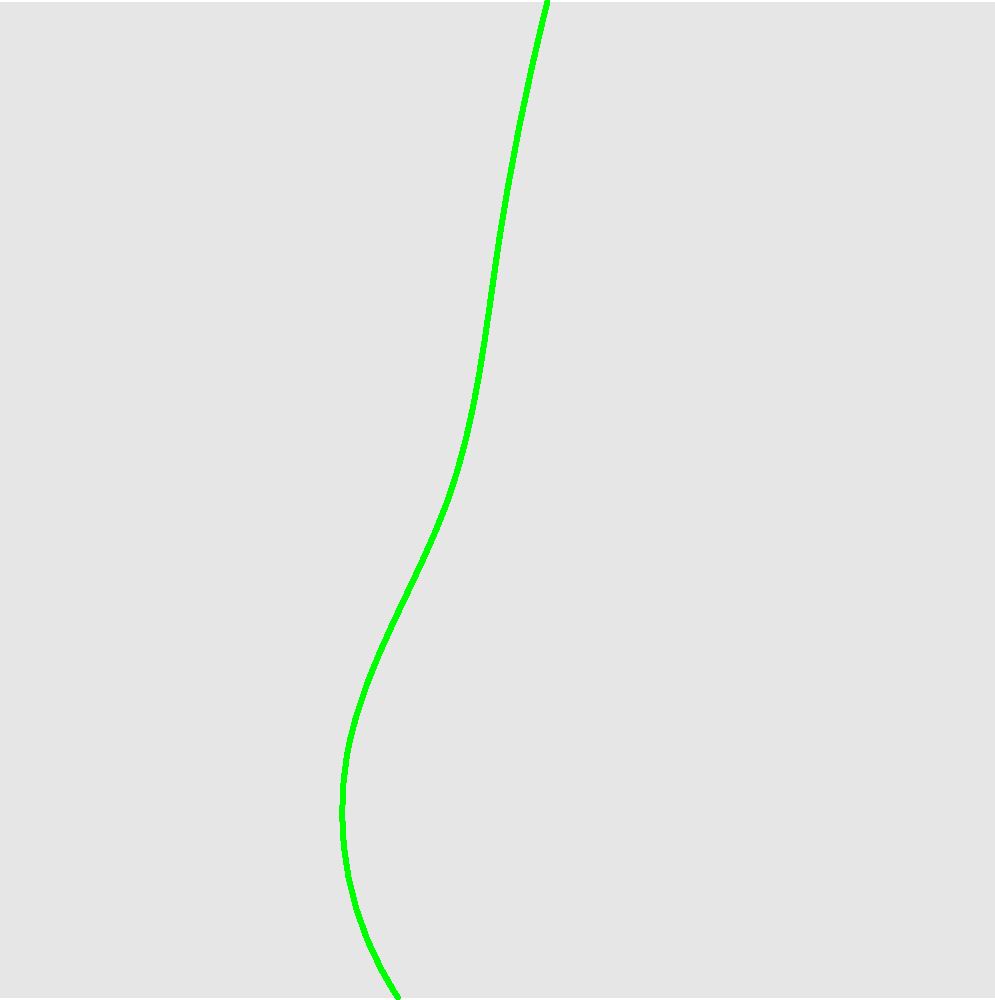In image segmentation for complex scenes, what advanced technique would you employ to effectively separate the foreground elements (such as the trees and house) from the background and noise in the given image, considering the irregular shapes and potential overlapping of objects? To effectively separate foreground elements from the background and noise in complex images, we can employ advanced segmentation techniques. Here's a step-by-step approach:

1. Preprocessing:
   - Apply noise reduction filters (e.g., Gaussian or median) to reduce the impact of random noise.
   - Enhance contrast to make foreground elements more distinguishable.

2. Initial Segmentation:
   - Use edge detection algorithms (e.g., Canny or Sobel) to identify object boundaries.
   - Apply thresholding techniques to create an initial binary mask.

3. Advanced Segmentation:
   - Implement a Convolutional Neural Network (CNN) based semantic segmentation model, such as U-Net or Mask R-CNN.
   - Train the model on a dataset of similar complex images with annotated foreground and background elements.

4. Post-processing:
   - Apply morphological operations (e.g., dilation and erosion) to refine object boundaries.
   - Use connected component analysis to identify and label distinct objects.

5. Refinement:
   - Employ Graph Cut algorithms to optimize the segmentation boundaries.
   - Utilize active contour models (e.g., Snake algorithm or Level Set Method) for precise boundary delineation.

6. Handling Overlapping Objects:
   - Implement instance segmentation techniques to separate individual objects, even when overlapping.
   - Use depth estimation or 3D reconstruction methods if additional depth information is available.

7. Evaluation and Iteration:
   - Assess the segmentation quality using metrics like Intersection over Union (IoU) or Dice coefficient.
   - Iteratively refine the model and parameters based on the evaluation results.

The most effective technique for this complex scene would be a deep learning-based approach, specifically a CNN architecture like Mask R-CNN, combined with post-processing techniques. This method can handle irregular shapes, overlapping objects, and distinguish between foreground elements and background noise effectively.
Answer: Mask R-CNN with post-processing 